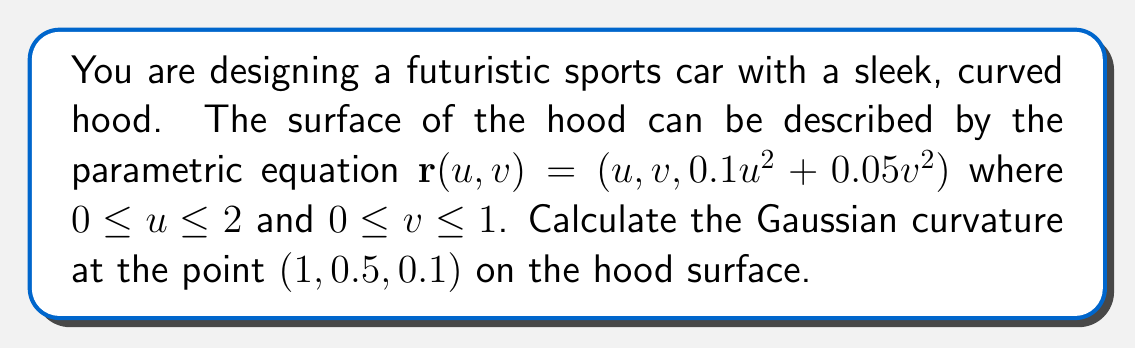Solve this math problem. To calculate the Gaussian curvature, we need to follow these steps:

1. Calculate the partial derivatives:
   $$\mathbf{r}_u = (1, 0, 0.2u)$$
   $$\mathbf{r}_v = (0, 1, 0.1v)$$
   $$\mathbf{r}_{uu} = (0, 0, 0.2)$$
   $$\mathbf{r}_{uv} = (0, 0, 0)$$
   $$\mathbf{r}_{vv} = (0, 0, 0.1)$$

2. Calculate the normal vector:
   $$\mathbf{N} = \frac{\mathbf{r}_u \times \mathbf{r}_v}{|\mathbf{r}_u \times \mathbf{r}_v|}$$
   $$\mathbf{N} = \frac{(-0.2u, -0.1v, 1)}{\sqrt{1 + 0.04u^2 + 0.01v^2}}$$

3. Calculate the coefficients of the first fundamental form:
   $$E = \mathbf{r}_u \cdot \mathbf{r}_u = 1 + 0.04u^2$$
   $$F = \mathbf{r}_u \cdot \mathbf{r}_v = 0$$
   $$G = \mathbf{r}_v \cdot \mathbf{r}_v = 1 + 0.01v^2$$

4. Calculate the coefficients of the second fundamental form:
   $$e = \mathbf{r}_{uu} \cdot \mathbf{N} = \frac{0.2}{\sqrt{1 + 0.04u^2 + 0.01v^2}}$$
   $$f = \mathbf{r}_{uv} \cdot \mathbf{N} = 0$$
   $$g = \mathbf{r}_{vv} \cdot \mathbf{N} = \frac{0.1}{\sqrt{1 + 0.04u^2 + 0.01v^2}}$$

5. Calculate the Gaussian curvature:
   $$K = \frac{eg - f^2}{EG - F^2}$$

6. Substitute the point $(1, 0.5, 0.1)$ into the equation:
   $$K = \frac{(0.2 \cdot 0.1 - 0^2)}{(1.04 \cdot 1.0025 - 0^2)} \cdot \frac{1}{1 + 0.04 \cdot 1^2 + 0.01 \cdot 0.5^2}$$

7. Simplify and calculate the final result:
   $$K = \frac{0.02}{1.04275} \cdot \frac{1}{1.04125} \approx 0.0184$$
Answer: $K \approx 0.0184$ 